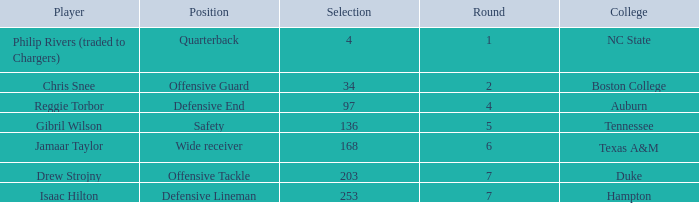Which Selection has a College of texas a&m? 168.0. 